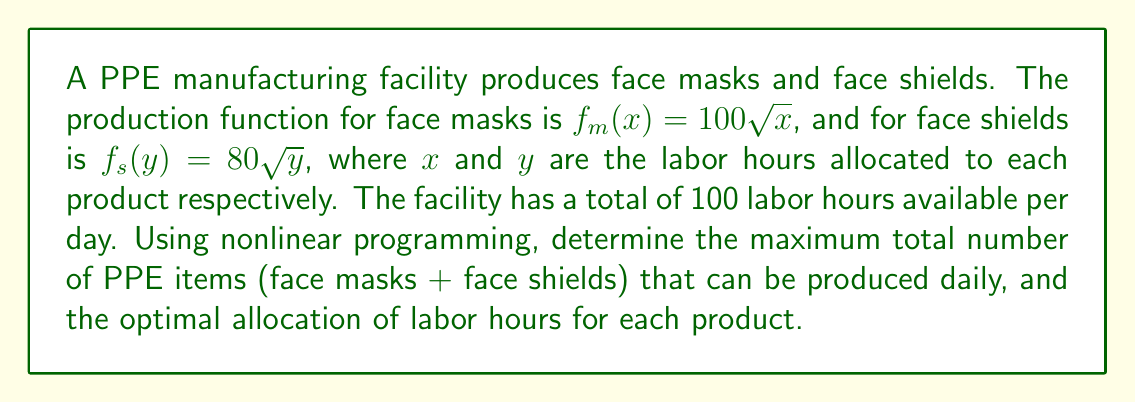Could you help me with this problem? 1. Define the objective function:
   Maximize $Z = f_m(x) + f_s(y) = 100\sqrt{x} + 80\sqrt{y}$

2. Define the constraint:
   $x + y \leq 100$ (total available labor hours)
   $x \geq 0, y \geq 0$ (non-negativity constraints)

3. Form the Lagrangian function:
   $L(x, y, \lambda) = 100\sqrt{x} + 80\sqrt{y} + \lambda(100 - x - y)$

4. Apply the Karush-Kuhn-Tucker (KKT) conditions:
   $\frac{\partial L}{\partial x} = \frac{50}{\sqrt{x}} - \lambda = 0$
   $\frac{\partial L}{\partial y} = \frac{40}{\sqrt{y}} - \lambda = 0$
   $\frac{\partial L}{\partial \lambda} = 100 - x - y = 0$

5. From the first two equations:
   $\frac{50}{\sqrt{x}} = \frac{40}{\sqrt{y}}$
   $\frac{25}{x} = \frac{16}{y}$
   $25y = 16x$

6. Substitute into the third equation:
   $100 - x - \frac{16x}{25} = 0$
   $100 - \frac{41x}{25} = 0$
   $x = \frac{2500}{41} \approx 60.98$

7. Calculate y:
   $y = 100 - x = 100 - 60.98 = 39.02$

8. Calculate the maximum production:
   $Z = 100\sqrt{60.98} + 80\sqrt{39.02} \approx 1280$

Therefore, the maximum total number of PPE items that can be produced daily is approximately 1280, with an optimal allocation of about 61 labor hours for face masks and 39 labor hours for face shields.
Answer: 1280 PPE items; 61 hours for masks, 39 hours for shields 